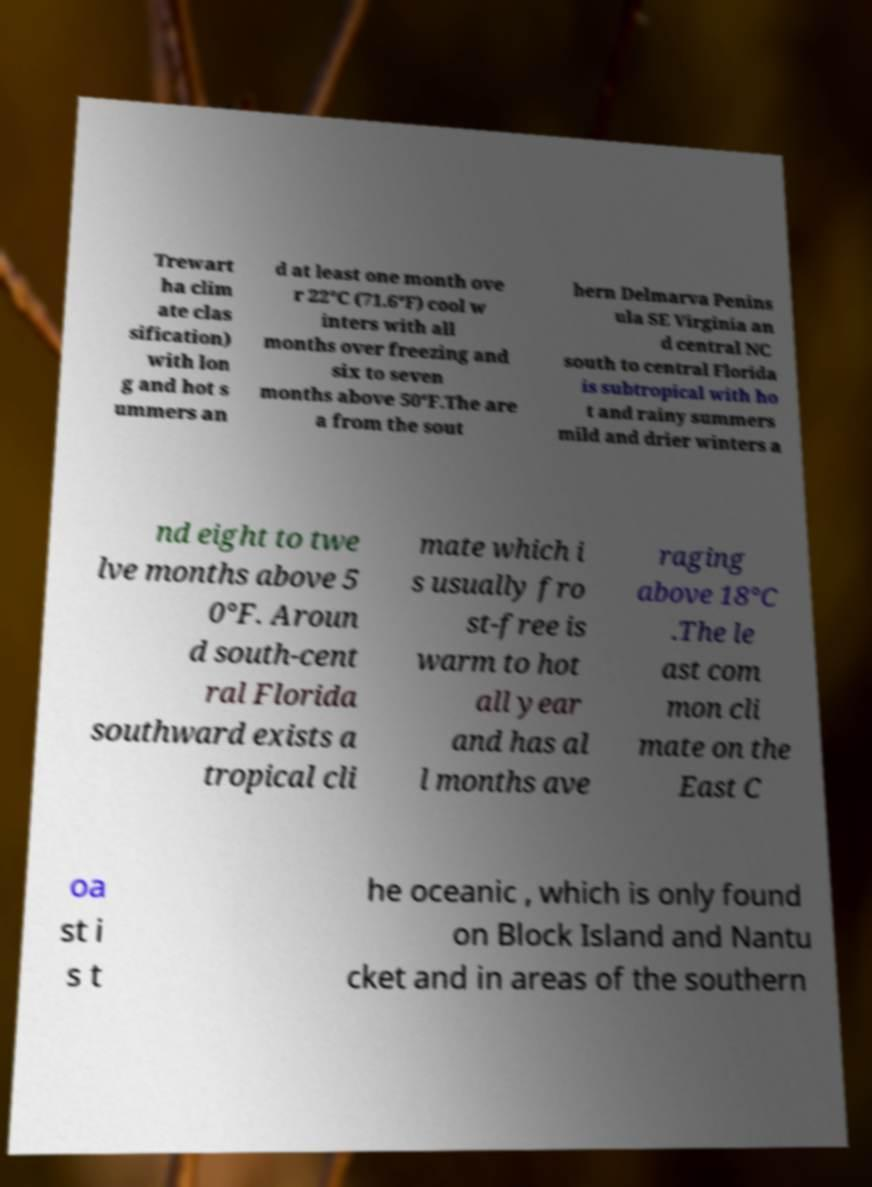Please read and relay the text visible in this image. What does it say? Trewart ha clim ate clas sification) with lon g and hot s ummers an d at least one month ove r 22°C (71.6°F) cool w inters with all months over freezing and six to seven months above 50°F.The are a from the sout hern Delmarva Penins ula SE Virginia an d central NC south to central Florida is subtropical with ho t and rainy summers mild and drier winters a nd eight to twe lve months above 5 0°F. Aroun d south-cent ral Florida southward exists a tropical cli mate which i s usually fro st-free is warm to hot all year and has al l months ave raging above 18°C .The le ast com mon cli mate on the East C oa st i s t he oceanic , which is only found on Block Island and Nantu cket and in areas of the southern 